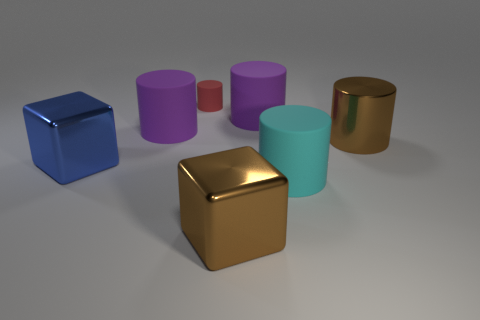What material is the large thing that is the same color as the metallic cylinder?
Make the answer very short. Metal. How many other things are the same material as the brown cube?
Provide a short and direct response. 2. There is a tiny thing; is its shape the same as the big purple matte object on the left side of the tiny red thing?
Your response must be concise. Yes. The cyan object that is the same material as the small red object is what shape?
Your answer should be very brief. Cylinder. Is the number of red rubber cylinders that are behind the large cyan thing greater than the number of big purple rubber cylinders to the left of the big blue metal block?
Your answer should be very brief. Yes. What number of things are either large brown objects or blue metallic things?
Your answer should be very brief. 3. How many other objects are the same color as the metallic cylinder?
Provide a succinct answer. 1. There is a cyan thing that is the same size as the brown block; what is its shape?
Provide a succinct answer. Cylinder. There is a big cube on the right side of the blue metal object; what is its color?
Your response must be concise. Brown. What number of objects are either big metallic cubes that are left of the brown cylinder or large matte cylinders that are on the left side of the cyan matte thing?
Offer a very short reply. 4. 